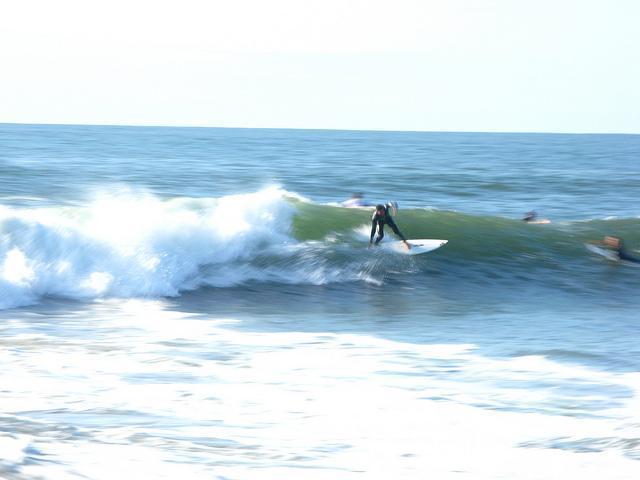How many people are in the water?
Give a very brief answer. 4. How many benches are there?
Give a very brief answer. 0. 